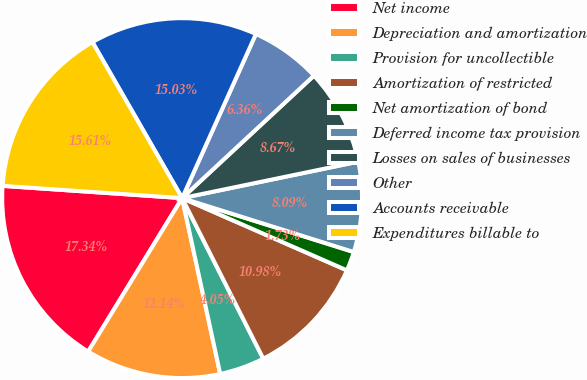Convert chart. <chart><loc_0><loc_0><loc_500><loc_500><pie_chart><fcel>Net income<fcel>Depreciation and amortization<fcel>Provision for uncollectible<fcel>Amortization of restricted<fcel>Net amortization of bond<fcel>Deferred income tax provision<fcel>Losses on sales of businesses<fcel>Other<fcel>Accounts receivable<fcel>Expenditures billable to<nl><fcel>17.34%<fcel>12.14%<fcel>4.05%<fcel>10.98%<fcel>1.73%<fcel>8.09%<fcel>8.67%<fcel>6.36%<fcel>15.03%<fcel>15.61%<nl></chart> 